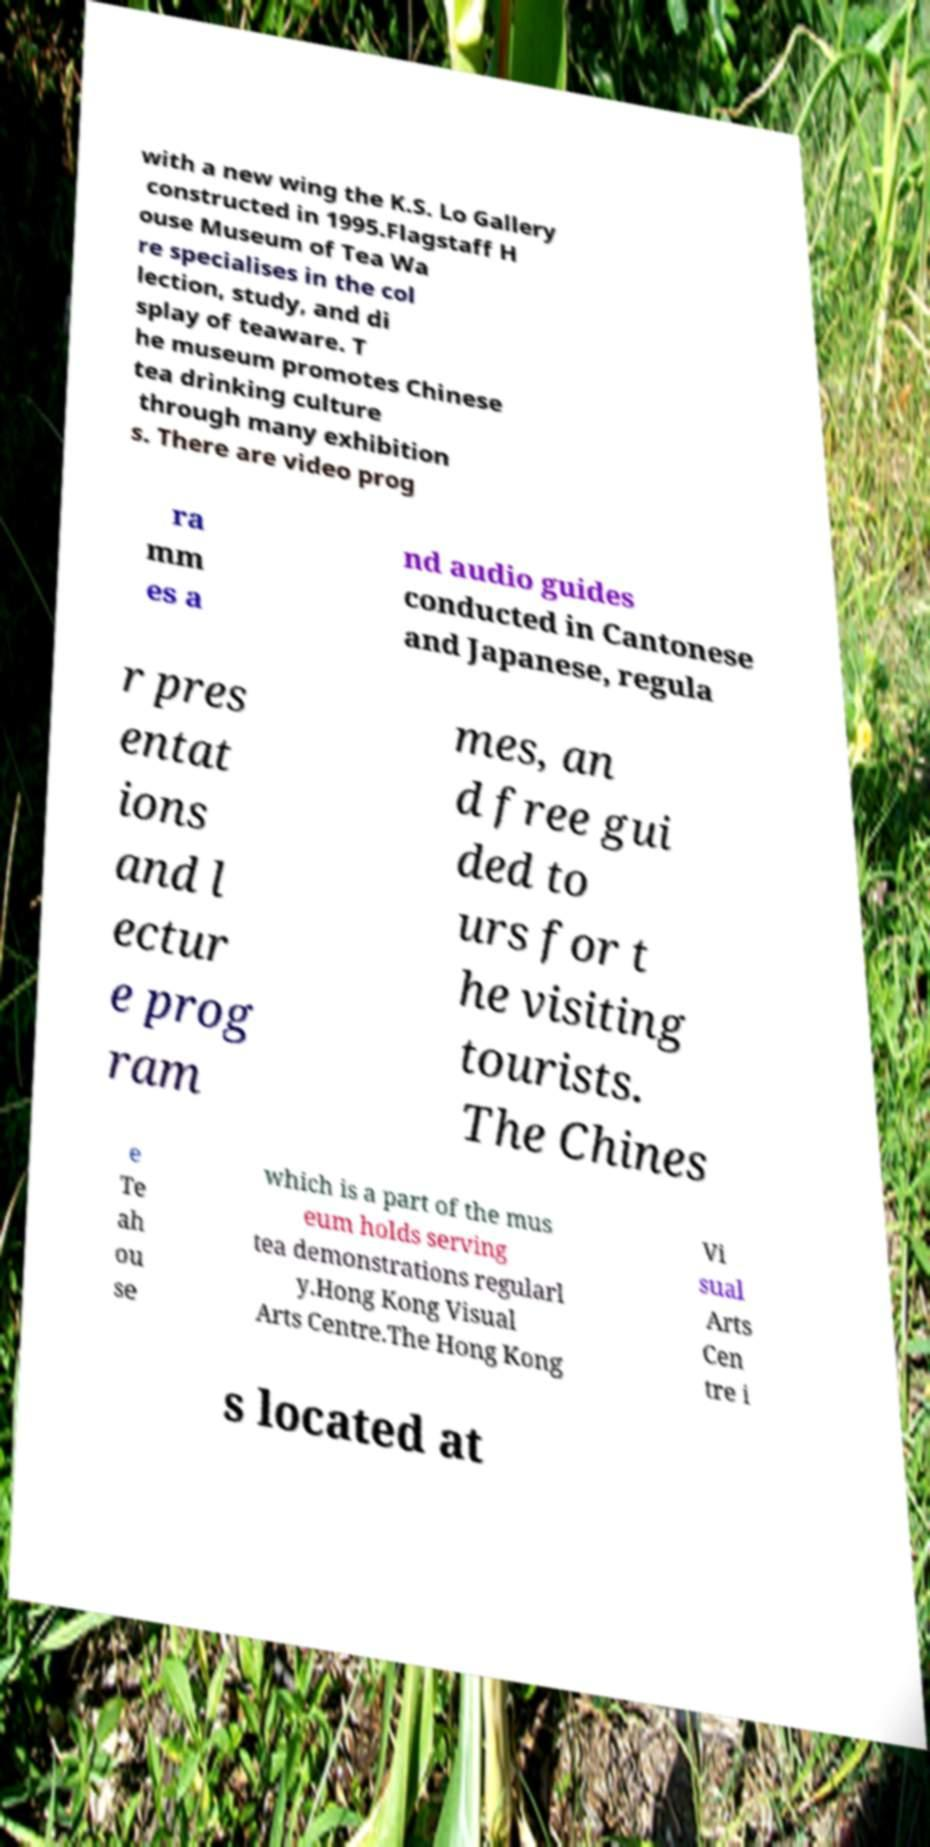For documentation purposes, I need the text within this image transcribed. Could you provide that? with a new wing the K.S. Lo Gallery constructed in 1995.Flagstaff H ouse Museum of Tea Wa re specialises in the col lection, study, and di splay of teaware. T he museum promotes Chinese tea drinking culture through many exhibition s. There are video prog ra mm es a nd audio guides conducted in Cantonese and Japanese, regula r pres entat ions and l ectur e prog ram mes, an d free gui ded to urs for t he visiting tourists. The Chines e Te ah ou se which is a part of the mus eum holds serving tea demonstrations regularl y.Hong Kong Visual Arts Centre.The Hong Kong Vi sual Arts Cen tre i s located at 